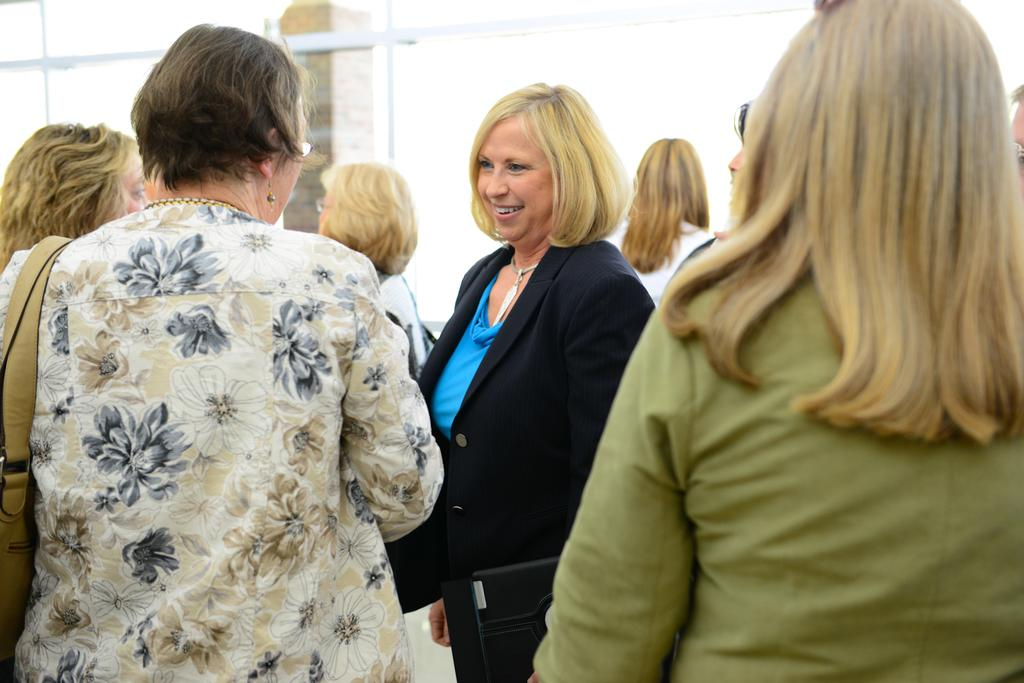How many women are in the image? There are women in the image, but the exact number is not specified. Can you describe the woman in the middle of the image? The woman in the middle is wearing a coat and smiling. What is present in the background of the image? There is a pillar in the background of the image. What type of lunchroom can be seen in the image? There is no lunchroom present in the image. What advice does the coach give to the women in the image? There is no coach or any indication of a coaching session in the image. 